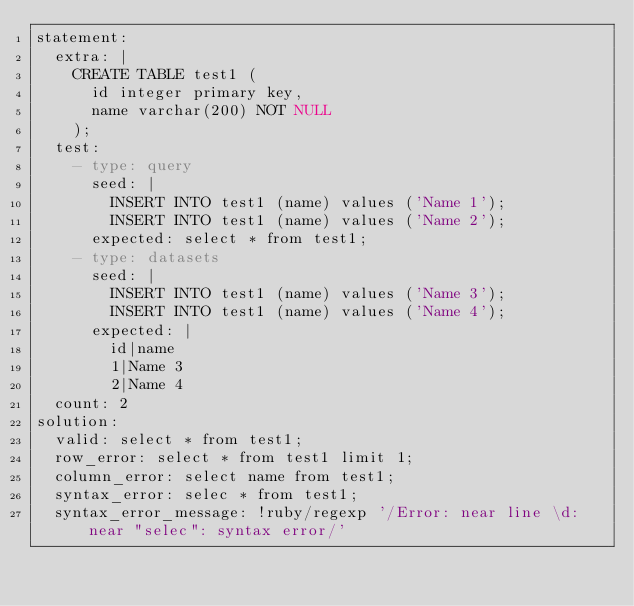<code> <loc_0><loc_0><loc_500><loc_500><_YAML_>statement:
  extra: |
    CREATE TABLE test1 (
      id integer primary key,
      name varchar(200) NOT NULL
    );
  test:
    - type: query
      seed: |
        INSERT INTO test1 (name) values ('Name 1');
        INSERT INTO test1 (name) values ('Name 2');
      expected: select * from test1;
    - type: datasets
      seed: |
        INSERT INTO test1 (name) values ('Name 3');
        INSERT INTO test1 (name) values ('Name 4');
      expected: |
        id|name
        1|Name 3
        2|Name 4
  count: 2
solution:
  valid: select * from test1;
  row_error: select * from test1 limit 1;
  column_error: select name from test1;
  syntax_error: selec * from test1;
  syntax_error_message: !ruby/regexp '/Error: near line \d: near "selec": syntax error/'
</code> 